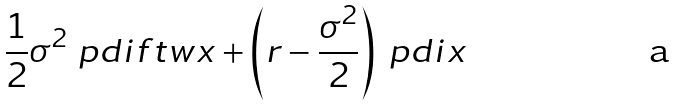Convert formula to latex. <formula><loc_0><loc_0><loc_500><loc_500>\frac { 1 } { 2 } \sigma ^ { 2 } \ p d i f t w { x } + \left ( r - \frac { \sigma ^ { 2 } } { 2 } \right ) \ p d i { x }</formula> 